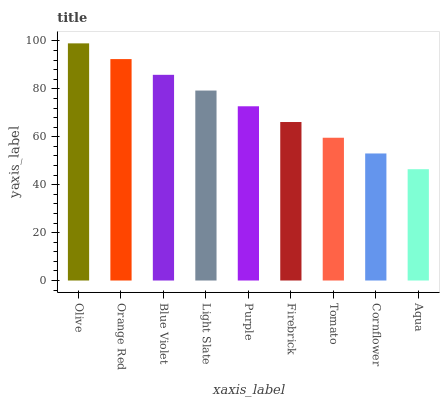Is Aqua the minimum?
Answer yes or no. Yes. Is Olive the maximum?
Answer yes or no. Yes. Is Orange Red the minimum?
Answer yes or no. No. Is Orange Red the maximum?
Answer yes or no. No. Is Olive greater than Orange Red?
Answer yes or no. Yes. Is Orange Red less than Olive?
Answer yes or no. Yes. Is Orange Red greater than Olive?
Answer yes or no. No. Is Olive less than Orange Red?
Answer yes or no. No. Is Purple the high median?
Answer yes or no. Yes. Is Purple the low median?
Answer yes or no. Yes. Is Olive the high median?
Answer yes or no. No. Is Tomato the low median?
Answer yes or no. No. 